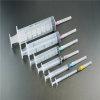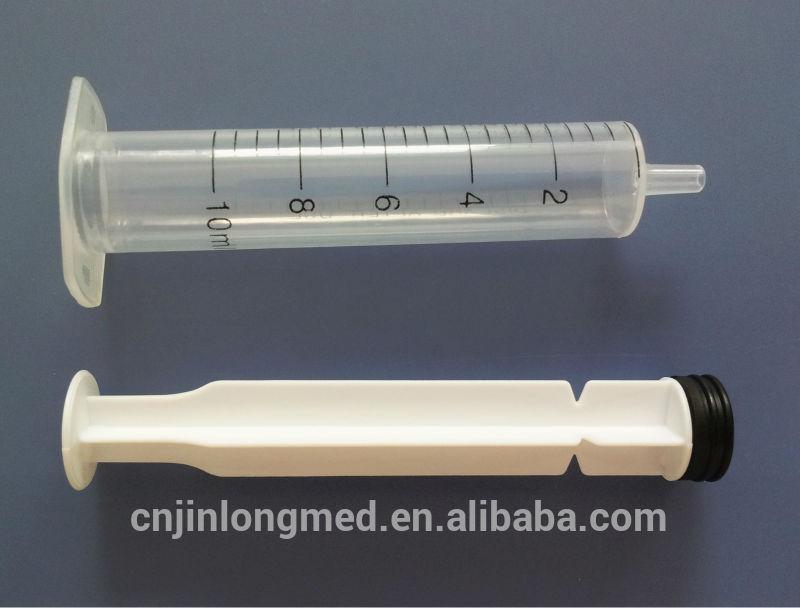The first image is the image on the left, the second image is the image on the right. Given the left and right images, does the statement "At least one of the images has exactly three syringes." hold true? Answer yes or no. No. The first image is the image on the left, the second image is the image on the right. Evaluate the accuracy of this statement regarding the images: "An image shows exactly two syringe-related items displayed horizontally.". Is it true? Answer yes or no. Yes. 